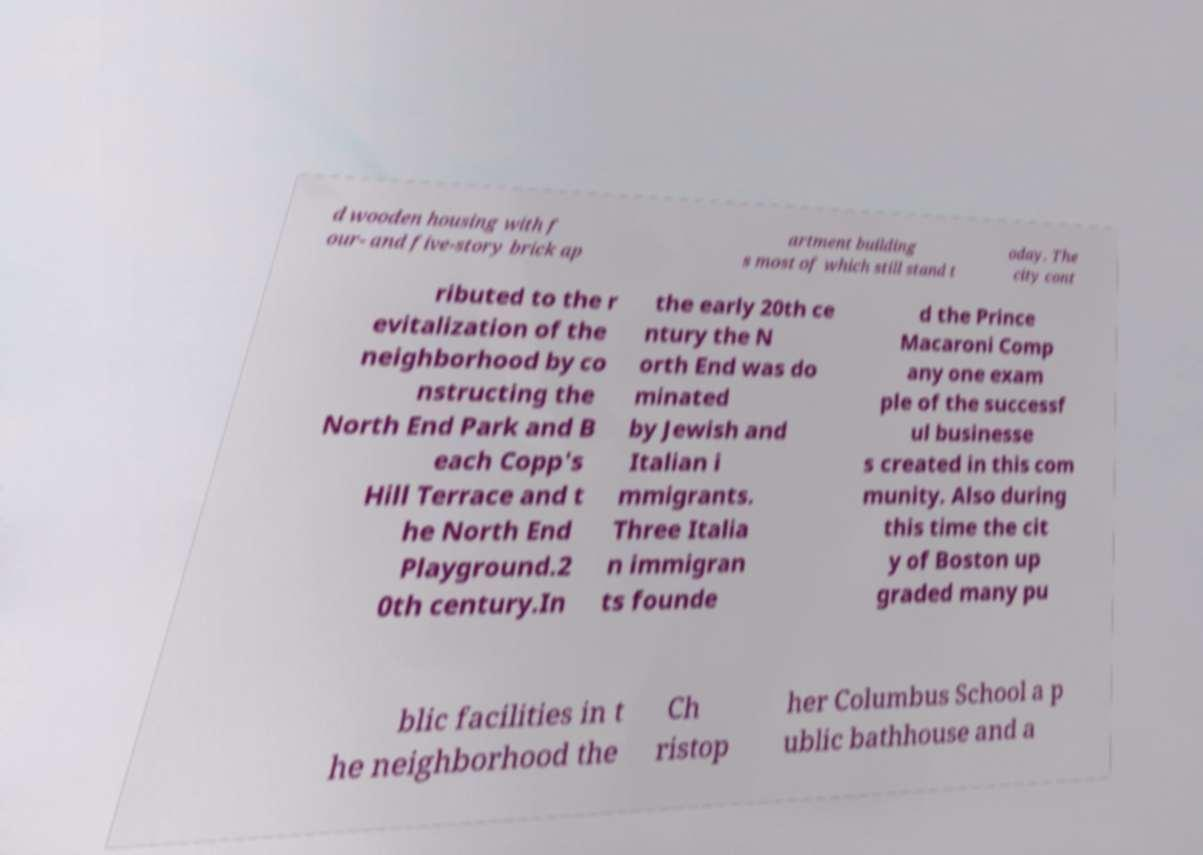Could you assist in decoding the text presented in this image and type it out clearly? d wooden housing with f our- and five-story brick ap artment building s most of which still stand t oday. The city cont ributed to the r evitalization of the neighborhood by co nstructing the North End Park and B each Copp's Hill Terrace and t he North End Playground.2 0th century.In the early 20th ce ntury the N orth End was do minated by Jewish and Italian i mmigrants. Three Italia n immigran ts founde d the Prince Macaroni Comp any one exam ple of the successf ul businesse s created in this com munity. Also during this time the cit y of Boston up graded many pu blic facilities in t he neighborhood the Ch ristop her Columbus School a p ublic bathhouse and a 